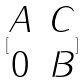<formula> <loc_0><loc_0><loc_500><loc_500>[ \begin{matrix} A & C \\ 0 & B \end{matrix} ]</formula> 